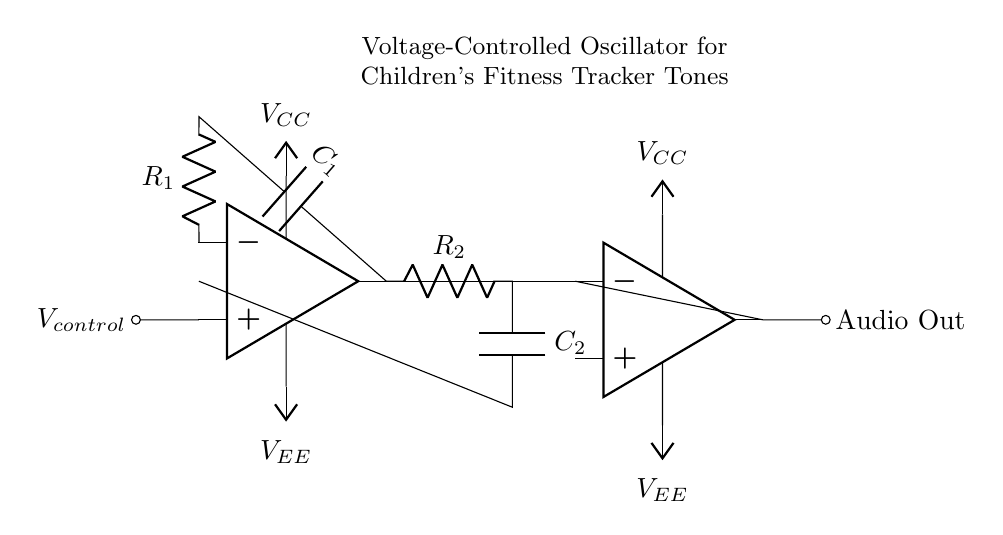What is the main function of this circuit? The main function is to generate audible tones, which can be used in children's fitness trackers for alerts or notifications. It serves a specific role in creating sound.
Answer: Generate audible tones What type of components are used in the feedback network? The feedback network consists of a resistor and a capacitor, specifically R2 and C2, which are crucial for determining the frequency of oscillation and signal shaping.
Answer: Resistor and capacitor What is the role of the op-amp in this circuit? The op-amp acts as a voltage amplifier that helps in generating oscillations based on the input control voltage and the feedback provided by R2 and C2.
Answer: Voltage amplifier What is the purpose of the control voltage? The control voltage adjusts the frequency of the oscillations generated by the circuit, allowing for dynamic tone generation based on user inputs or conditions.
Answer: Adjust frequency How many power supply connections are present in the circuit? There are two power supply connections for the op-amp and buffer, both require a positive and a negative voltage to operate, resulting in a total of four connections.
Answer: Four connections What happens if the control voltage is increased? Increasing the control voltage will typically result in higher frequency oscillations, leading to a higher pitch sound output from the audio out.
Answer: Higher pitch sound What type of oscillator is this circuit? This circuit is a voltage-controlled oscillator, specifically designed to modulate frequencies based on the input voltage fluctuations.
Answer: Voltage-controlled oscillator 